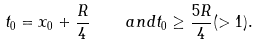<formula> <loc_0><loc_0><loc_500><loc_500>t _ { 0 } = x _ { 0 } + \frac { R } { 4 } \quad a n d t _ { 0 } \geq \frac { 5 R } { 4 } ( > 1 ) .</formula> 